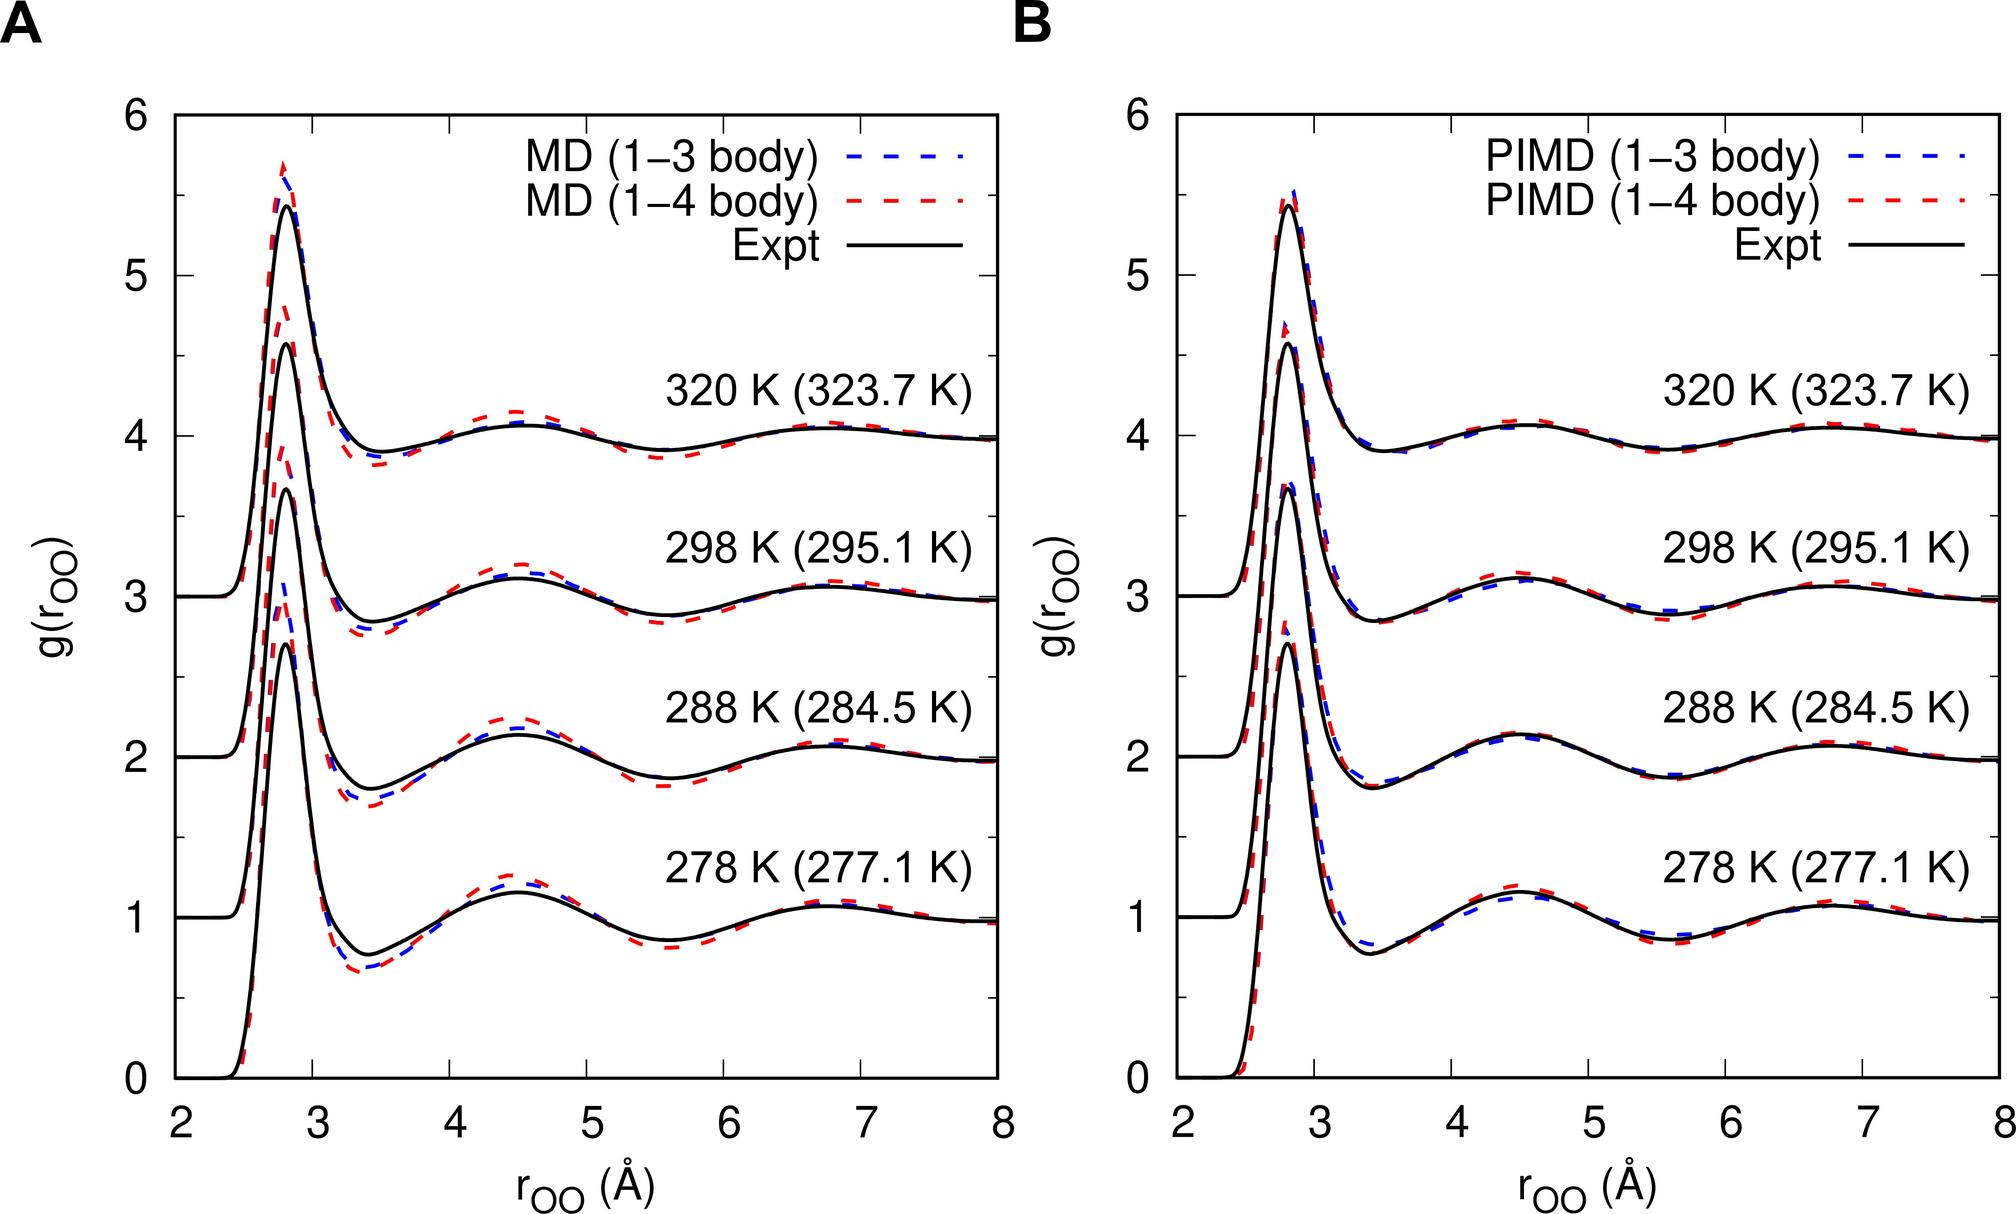How do the positions of first peaks differ amongst various methods in Figure B at 288 K? In Figure B at 288 K, the position of the first peak appears least varied among the methods, yet the MD (1-3 body) and PIMD (1-3 body) have slightly peak earlier than the MD (1-4 body) and PIMD (1-4 body). This indicates different modeling methods might slightly shift peak positions due to their molecular interaction interpretations. 